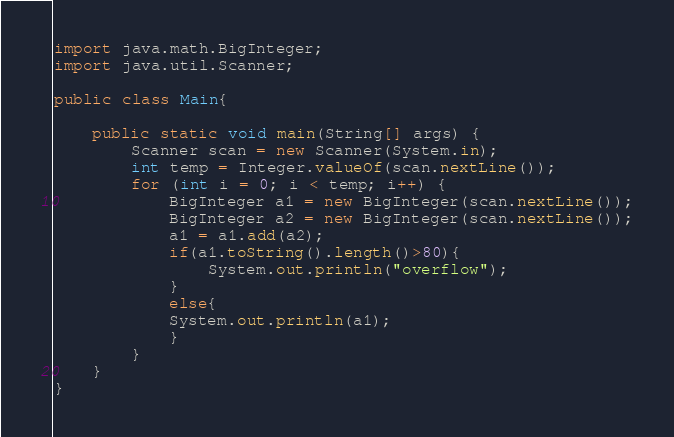Convert code to text. <code><loc_0><loc_0><loc_500><loc_500><_Java_>import java.math.BigInteger;
import java.util.Scanner;

public class Main{

	public static void main(String[] args) {
		Scanner scan = new Scanner(System.in);
		int temp = Integer.valueOf(scan.nextLine());
		for (int i = 0; i < temp; i++) {
			BigInteger a1 = new BigInteger(scan.nextLine());
			BigInteger a2 = new BigInteger(scan.nextLine());
			a1 = a1.add(a2);
			if(a1.toString().length()>80){
				System.out.println("overflow");
			}
			else{
			System.out.println(a1);
			}
		}
	}
}</code> 